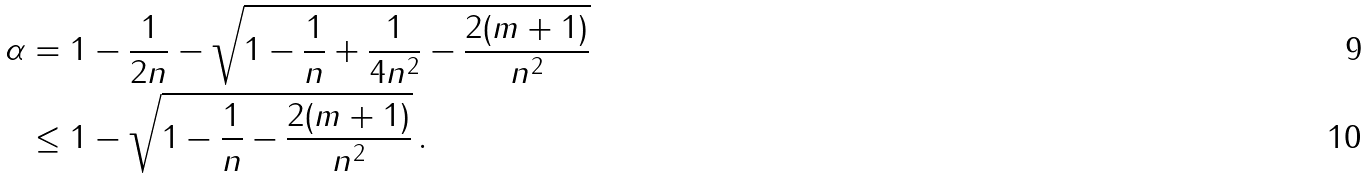Convert formula to latex. <formula><loc_0><loc_0><loc_500><loc_500>\alpha & = 1 - \frac { 1 } { 2 n } - \sqrt { 1 - \frac { 1 } { n } + \frac { 1 } { 4 n ^ { 2 } } - \frac { 2 ( m + 1 ) } { n ^ { 2 } } } \\ & \leq 1 - \sqrt { 1 - \frac { 1 } { n } - \frac { 2 ( m + 1 ) } { n ^ { 2 } } } \, .</formula> 